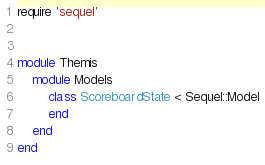Convert code to text. <code><loc_0><loc_0><loc_500><loc_500><_Ruby_>require 'sequel'


module Themis
    module Models
        class ScoreboardState < Sequel::Model
        end
    end
end
</code> 